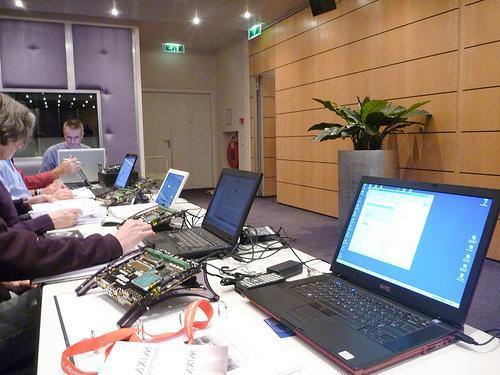How many computers are in this photo?
Give a very brief answer. 5. How many people are facing the camera?
Give a very brief answer. 1. 